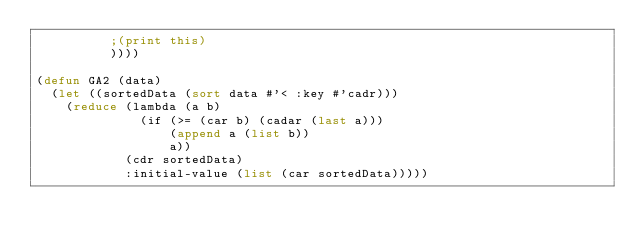Convert code to text. <code><loc_0><loc_0><loc_500><loc_500><_Lisp_>          ;(print this)
          ))))

(defun GA2 (data)
  (let ((sortedData (sort data #'< :key #'cadr)))
    (reduce (lambda (a b)
              (if (>= (car b) (cadar (last a)))
                  (append a (list b))
                  a))
            (cdr sortedData)
            :initial-value (list (car sortedData)))))
</code> 